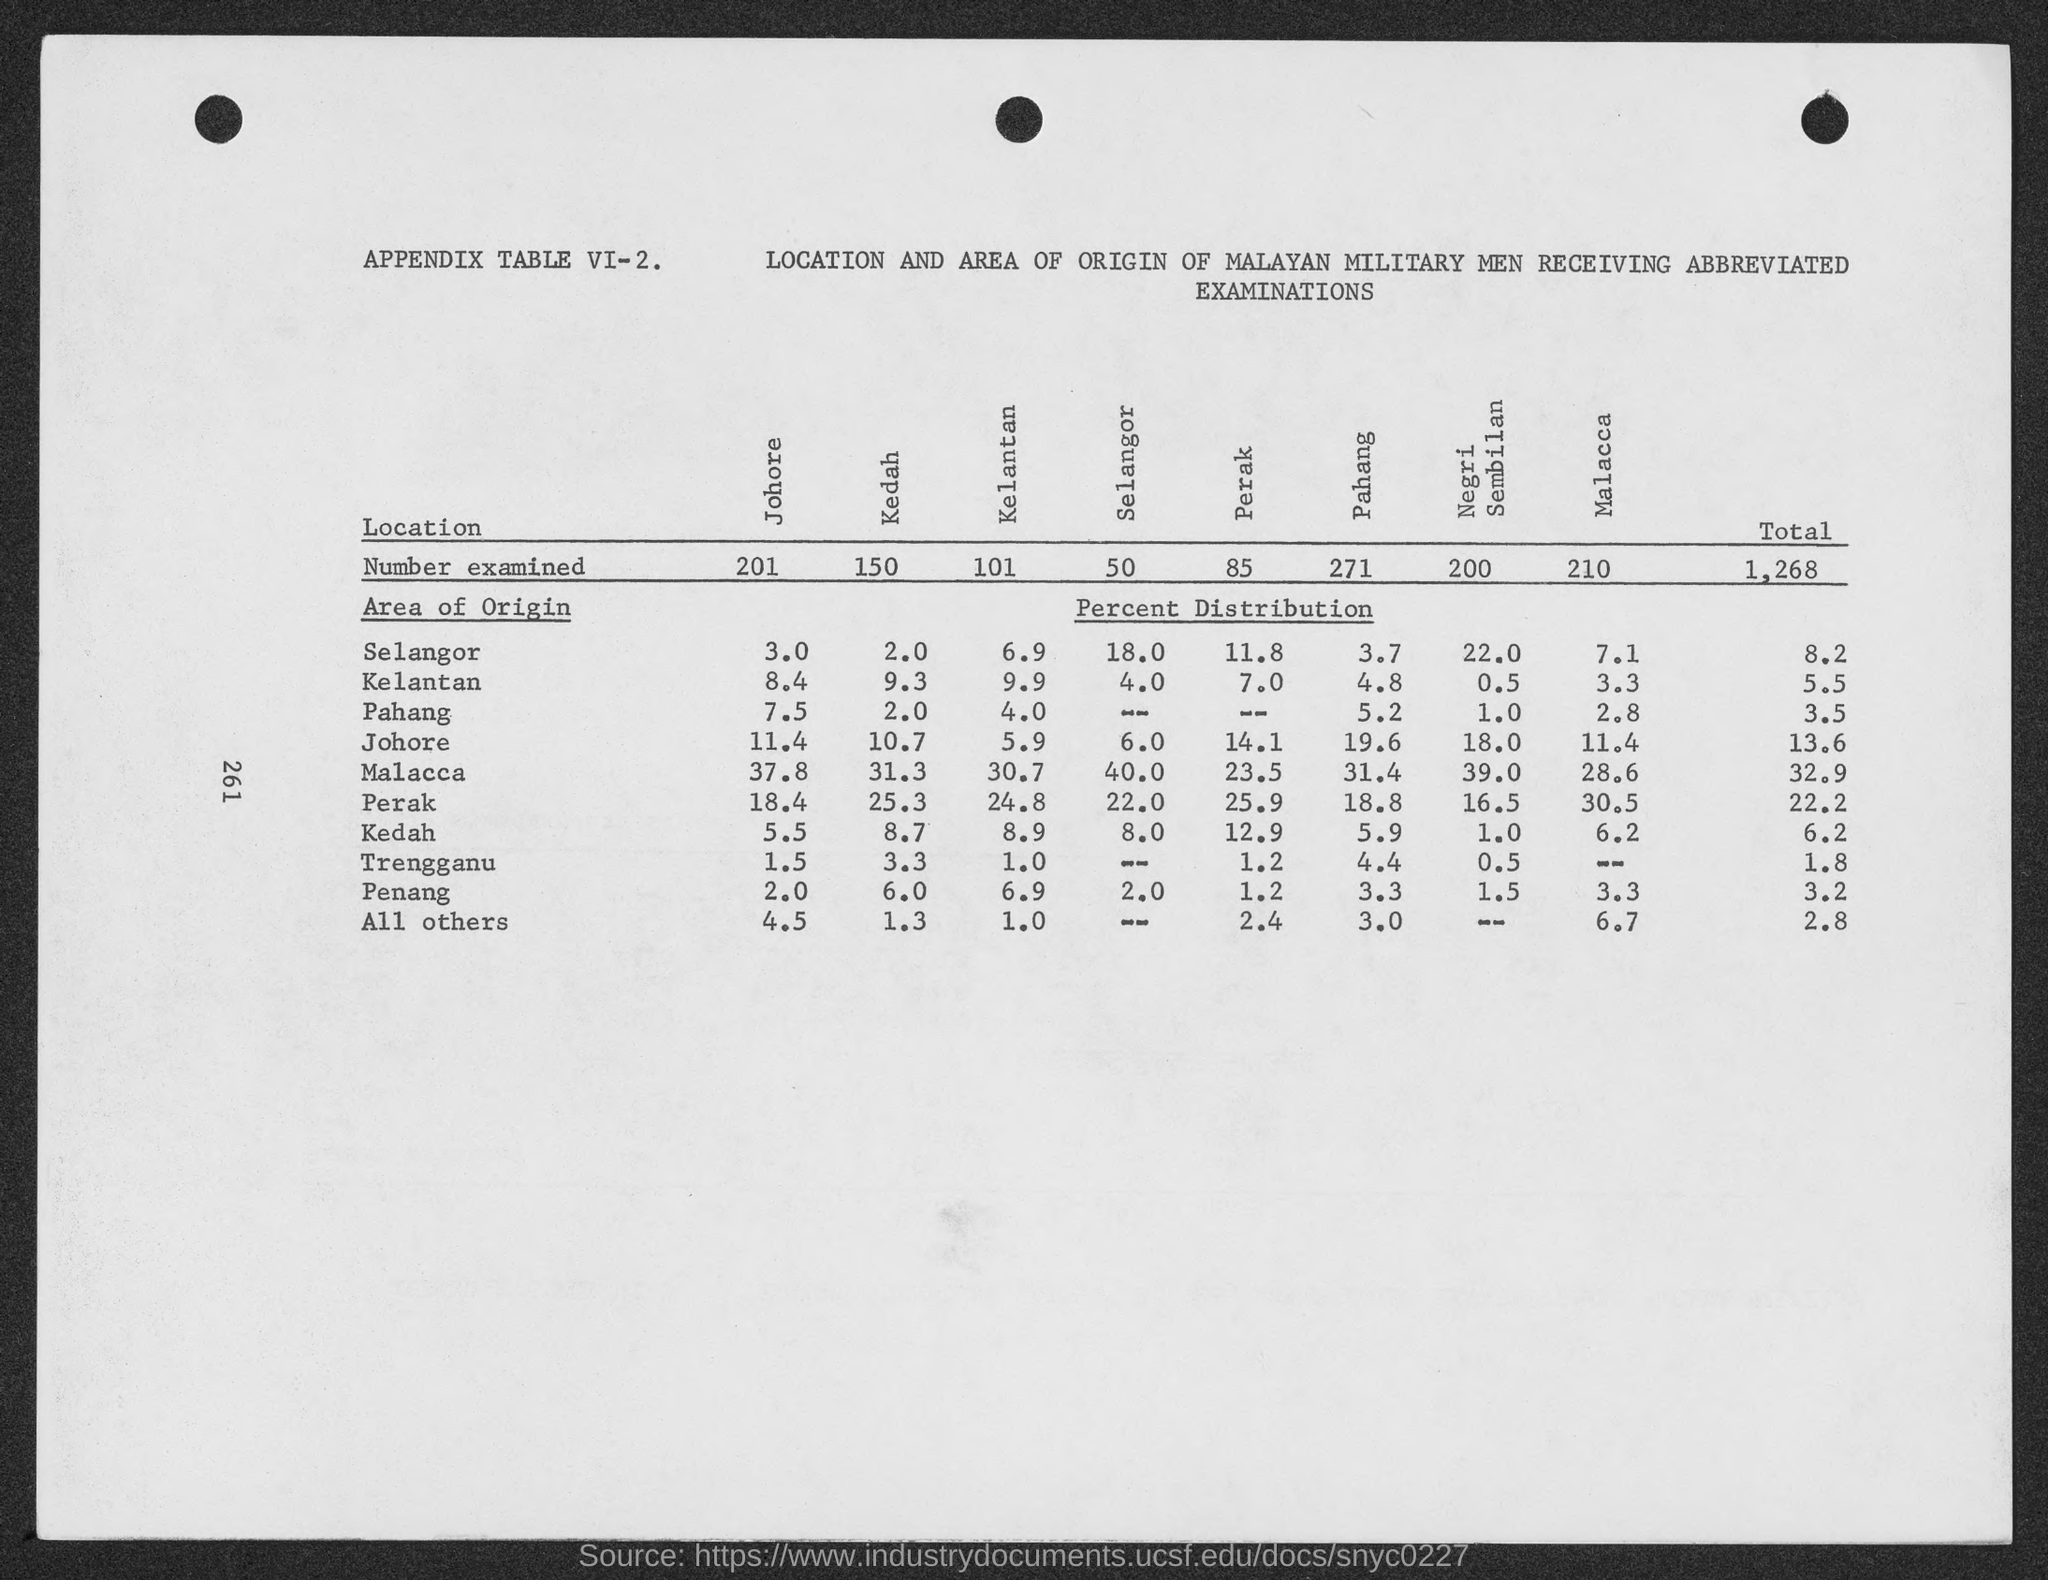What is the number of examined for kedah?
Keep it short and to the point. 150. What is the total number of examined?
Offer a terse response. 1,268. 